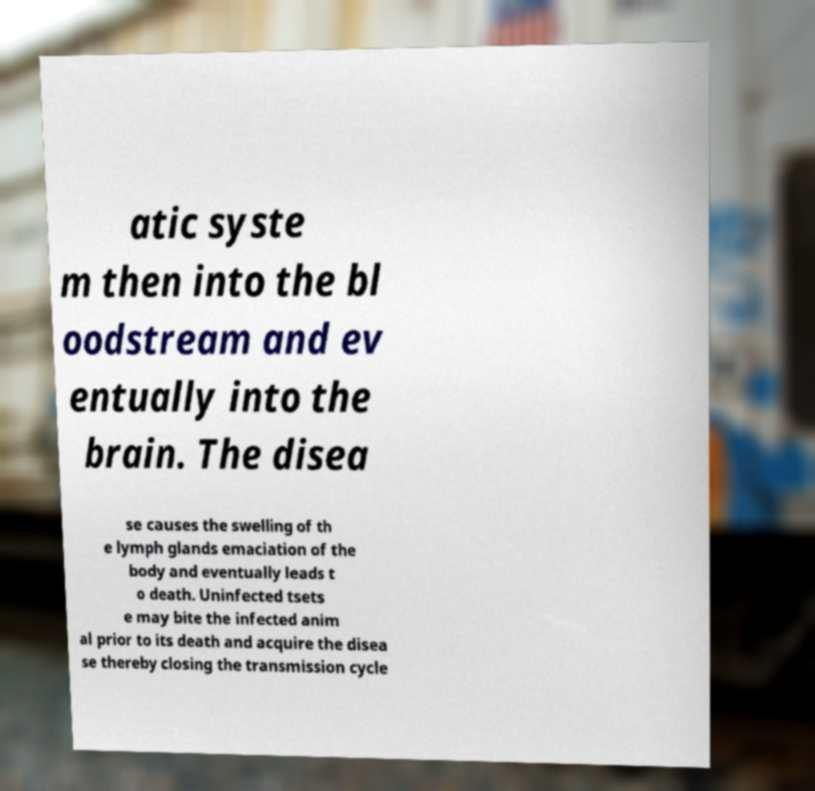Please read and relay the text visible in this image. What does it say? atic syste m then into the bl oodstream and ev entually into the brain. The disea se causes the swelling of th e lymph glands emaciation of the body and eventually leads t o death. Uninfected tsets e may bite the infected anim al prior to its death and acquire the disea se thereby closing the transmission cycle 